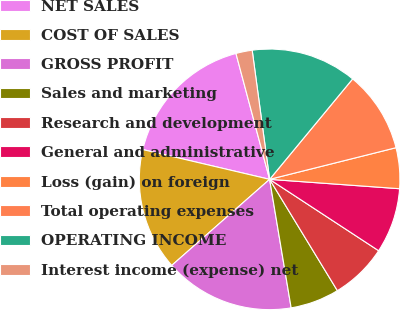<chart> <loc_0><loc_0><loc_500><loc_500><pie_chart><fcel>NET SALES<fcel>COST OF SALES<fcel>GROSS PROFIT<fcel>Sales and marketing<fcel>Research and development<fcel>General and administrative<fcel>Loss (gain) on foreign<fcel>Total operating expenses<fcel>OPERATING INCOME<fcel>Interest income (expense) net<nl><fcel>17.17%<fcel>15.15%<fcel>16.16%<fcel>6.06%<fcel>7.07%<fcel>8.08%<fcel>5.05%<fcel>10.1%<fcel>13.13%<fcel>2.02%<nl></chart> 